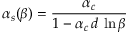<formula> <loc_0><loc_0><loc_500><loc_500>\alpha _ { s } ( \beta ) = \frac { \alpha _ { c } } { 1 - \alpha _ { c } \, d \, \ln \beta }</formula> 